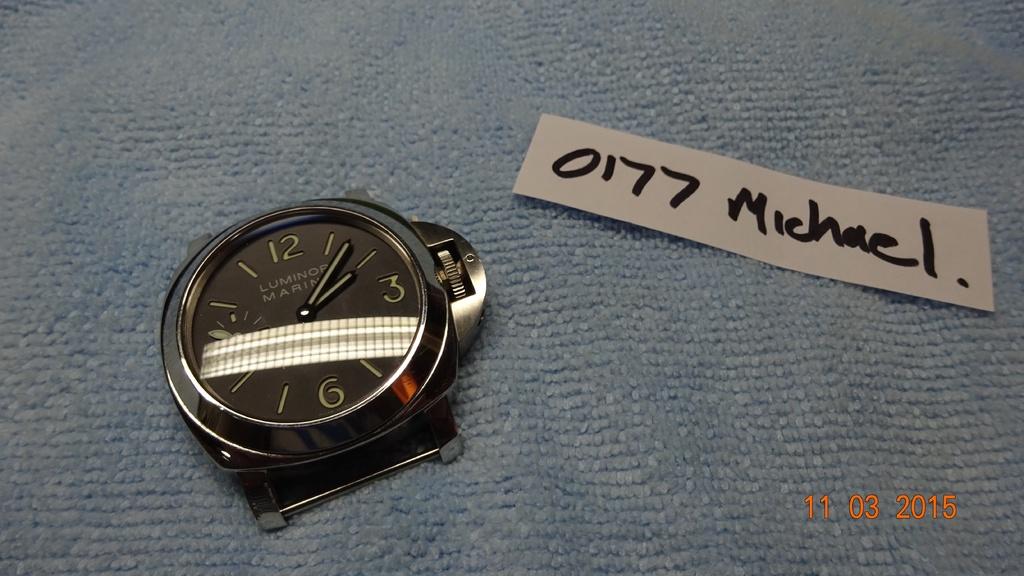What brand of watch is this?
Ensure brevity in your answer.  Luminor. The model number is written on the paper?
Your answer should be very brief. 0177. 